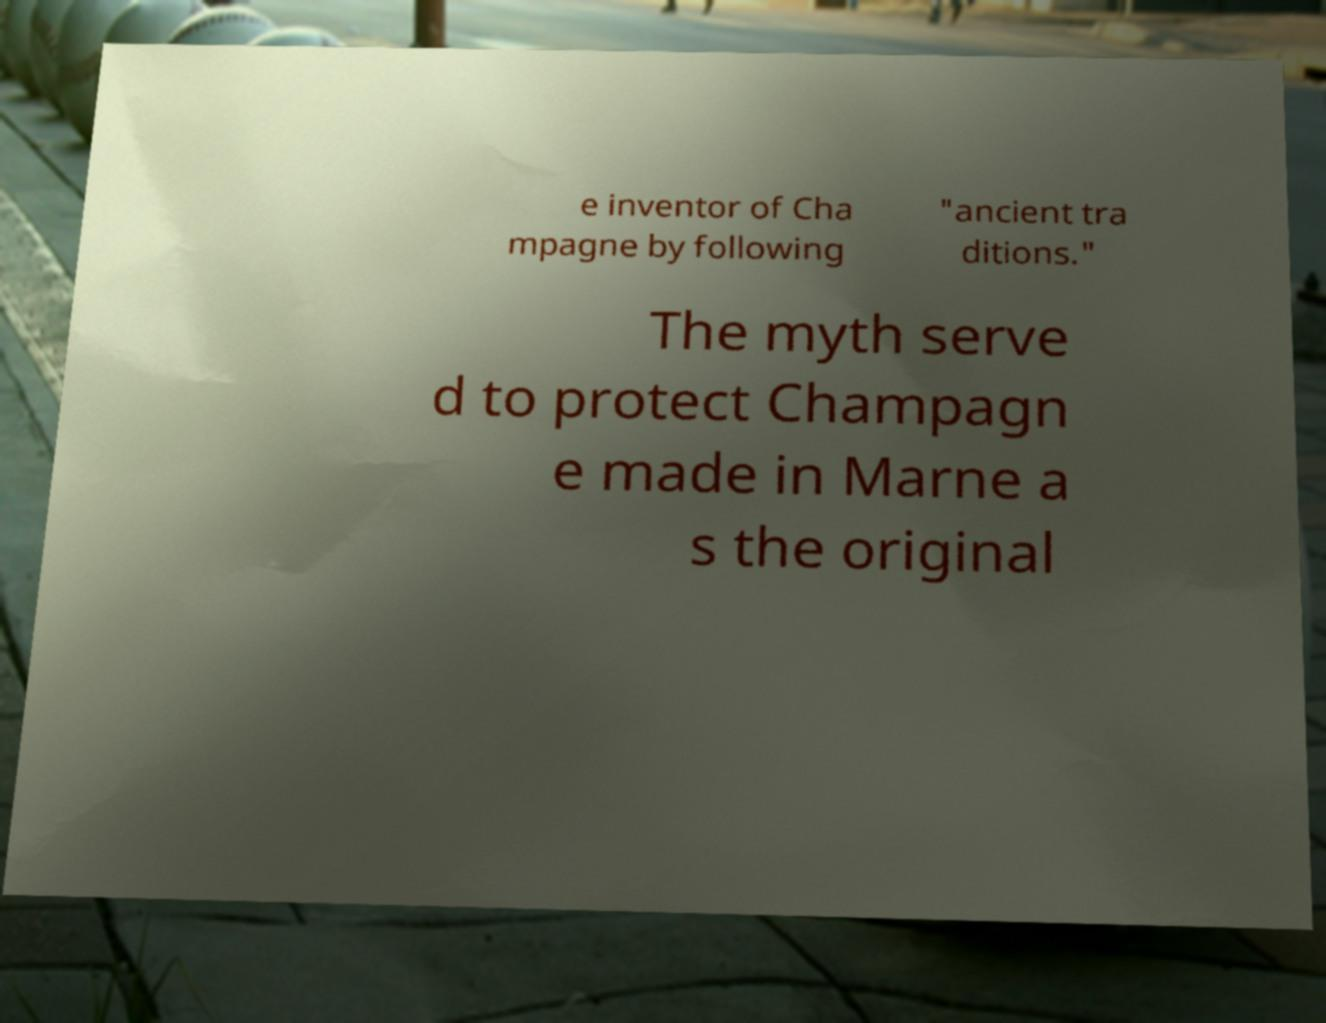Please read and relay the text visible in this image. What does it say? e inventor of Cha mpagne by following "ancient tra ditions." The myth serve d to protect Champagn e made in Marne a s the original 